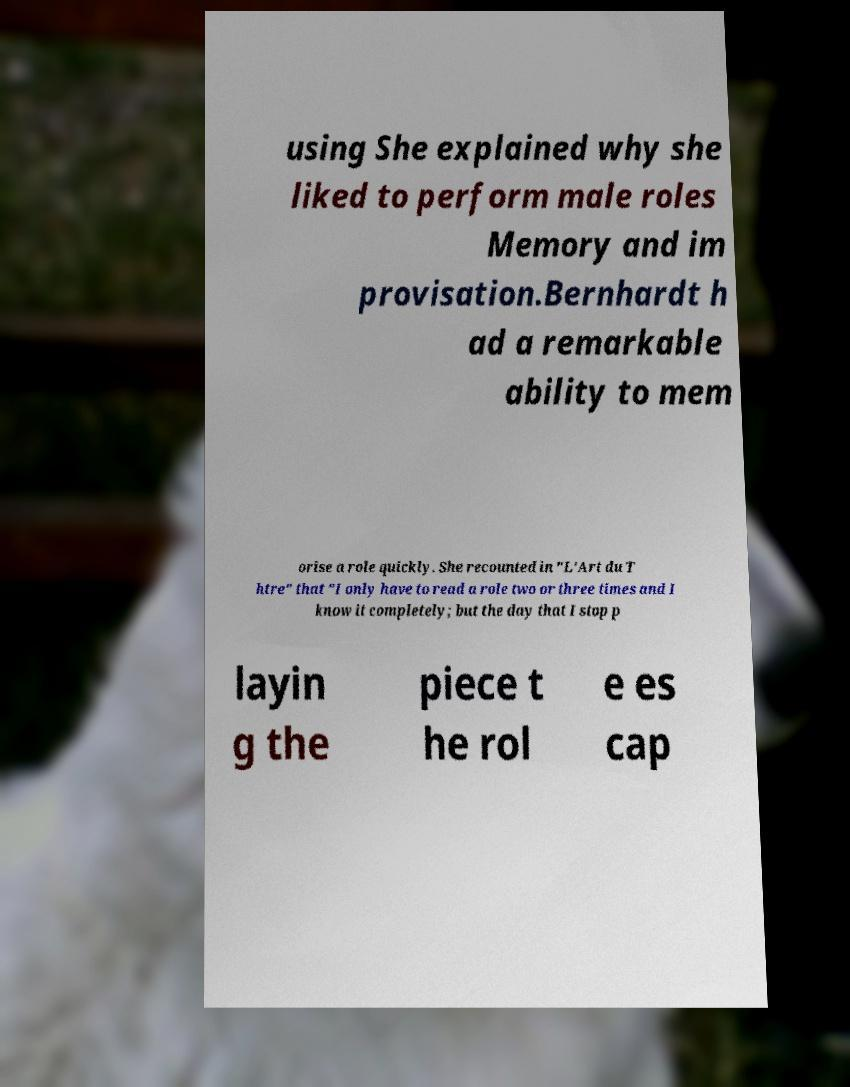There's text embedded in this image that I need extracted. Can you transcribe it verbatim? using She explained why she liked to perform male roles Memory and im provisation.Bernhardt h ad a remarkable ability to mem orise a role quickly. She recounted in "L'Art du T htre" that "I only have to read a role two or three times and I know it completely; but the day that I stop p layin g the piece t he rol e es cap 